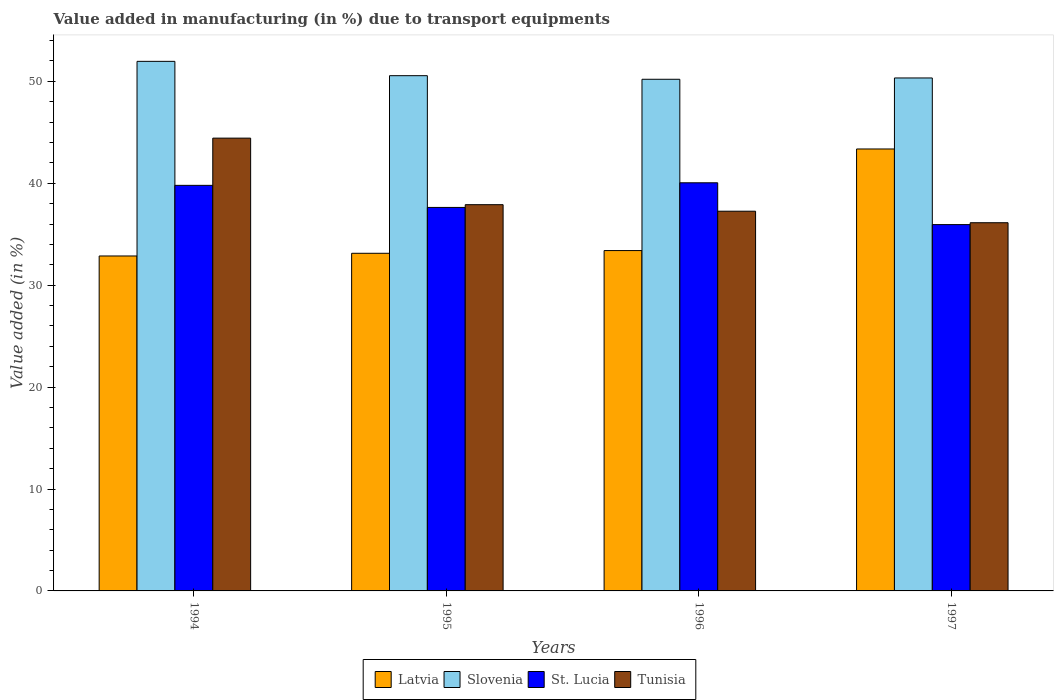How many different coloured bars are there?
Make the answer very short. 4. How many groups of bars are there?
Offer a terse response. 4. Are the number of bars on each tick of the X-axis equal?
Give a very brief answer. Yes. How many bars are there on the 1st tick from the left?
Your response must be concise. 4. How many bars are there on the 4th tick from the right?
Ensure brevity in your answer.  4. In how many cases, is the number of bars for a given year not equal to the number of legend labels?
Ensure brevity in your answer.  0. What is the percentage of value added in manufacturing due to transport equipments in Tunisia in 1994?
Offer a very short reply. 44.43. Across all years, what is the maximum percentage of value added in manufacturing due to transport equipments in Slovenia?
Give a very brief answer. 51.96. Across all years, what is the minimum percentage of value added in manufacturing due to transport equipments in Slovenia?
Make the answer very short. 50.2. In which year was the percentage of value added in manufacturing due to transport equipments in Tunisia maximum?
Provide a succinct answer. 1994. What is the total percentage of value added in manufacturing due to transport equipments in Latvia in the graph?
Ensure brevity in your answer.  142.75. What is the difference between the percentage of value added in manufacturing due to transport equipments in Slovenia in 1995 and that in 1996?
Make the answer very short. 0.35. What is the difference between the percentage of value added in manufacturing due to transport equipments in St. Lucia in 1996 and the percentage of value added in manufacturing due to transport equipments in Tunisia in 1994?
Ensure brevity in your answer.  -4.38. What is the average percentage of value added in manufacturing due to transport equipments in Slovenia per year?
Offer a very short reply. 50.76. In the year 1995, what is the difference between the percentage of value added in manufacturing due to transport equipments in Slovenia and percentage of value added in manufacturing due to transport equipments in Latvia?
Keep it short and to the point. 17.43. What is the ratio of the percentage of value added in manufacturing due to transport equipments in St. Lucia in 1996 to that in 1997?
Ensure brevity in your answer.  1.11. Is the percentage of value added in manufacturing due to transport equipments in Slovenia in 1996 less than that in 1997?
Provide a short and direct response. Yes. What is the difference between the highest and the second highest percentage of value added in manufacturing due to transport equipments in Slovenia?
Offer a terse response. 1.41. What is the difference between the highest and the lowest percentage of value added in manufacturing due to transport equipments in Latvia?
Ensure brevity in your answer.  10.5. Is the sum of the percentage of value added in manufacturing due to transport equipments in Tunisia in 1995 and 1997 greater than the maximum percentage of value added in manufacturing due to transport equipments in Latvia across all years?
Provide a short and direct response. Yes. What does the 3rd bar from the left in 1995 represents?
Your answer should be compact. St. Lucia. What does the 4th bar from the right in 1997 represents?
Keep it short and to the point. Latvia. Is it the case that in every year, the sum of the percentage of value added in manufacturing due to transport equipments in Slovenia and percentage of value added in manufacturing due to transport equipments in St. Lucia is greater than the percentage of value added in manufacturing due to transport equipments in Tunisia?
Keep it short and to the point. Yes. How many bars are there?
Provide a short and direct response. 16. Are all the bars in the graph horizontal?
Offer a very short reply. No. What is the difference between two consecutive major ticks on the Y-axis?
Ensure brevity in your answer.  10. Are the values on the major ticks of Y-axis written in scientific E-notation?
Provide a succinct answer. No. Where does the legend appear in the graph?
Provide a short and direct response. Bottom center. How are the legend labels stacked?
Your answer should be compact. Horizontal. What is the title of the graph?
Your answer should be compact. Value added in manufacturing (in %) due to transport equipments. What is the label or title of the Y-axis?
Your answer should be very brief. Value added (in %). What is the Value added (in %) in Latvia in 1994?
Your response must be concise. 32.86. What is the Value added (in %) in Slovenia in 1994?
Your response must be concise. 51.96. What is the Value added (in %) of St. Lucia in 1994?
Give a very brief answer. 39.79. What is the Value added (in %) in Tunisia in 1994?
Offer a very short reply. 44.43. What is the Value added (in %) of Latvia in 1995?
Offer a very short reply. 33.13. What is the Value added (in %) of Slovenia in 1995?
Provide a short and direct response. 50.55. What is the Value added (in %) in St. Lucia in 1995?
Provide a succinct answer. 37.63. What is the Value added (in %) in Tunisia in 1995?
Keep it short and to the point. 37.9. What is the Value added (in %) of Latvia in 1996?
Offer a terse response. 33.39. What is the Value added (in %) of Slovenia in 1996?
Offer a terse response. 50.2. What is the Value added (in %) of St. Lucia in 1996?
Offer a terse response. 40.05. What is the Value added (in %) in Tunisia in 1996?
Your answer should be very brief. 37.26. What is the Value added (in %) of Latvia in 1997?
Your answer should be compact. 43.36. What is the Value added (in %) of Slovenia in 1997?
Keep it short and to the point. 50.33. What is the Value added (in %) in St. Lucia in 1997?
Give a very brief answer. 35.94. What is the Value added (in %) in Tunisia in 1997?
Give a very brief answer. 36.13. Across all years, what is the maximum Value added (in %) of Latvia?
Ensure brevity in your answer.  43.36. Across all years, what is the maximum Value added (in %) of Slovenia?
Provide a succinct answer. 51.96. Across all years, what is the maximum Value added (in %) of St. Lucia?
Your response must be concise. 40.05. Across all years, what is the maximum Value added (in %) in Tunisia?
Provide a succinct answer. 44.43. Across all years, what is the minimum Value added (in %) of Latvia?
Provide a succinct answer. 32.86. Across all years, what is the minimum Value added (in %) in Slovenia?
Provide a short and direct response. 50.2. Across all years, what is the minimum Value added (in %) in St. Lucia?
Ensure brevity in your answer.  35.94. Across all years, what is the minimum Value added (in %) in Tunisia?
Your answer should be compact. 36.13. What is the total Value added (in %) in Latvia in the graph?
Ensure brevity in your answer.  142.75. What is the total Value added (in %) of Slovenia in the graph?
Your response must be concise. 203.05. What is the total Value added (in %) of St. Lucia in the graph?
Give a very brief answer. 153.41. What is the total Value added (in %) of Tunisia in the graph?
Your answer should be very brief. 155.71. What is the difference between the Value added (in %) in Latvia in 1994 and that in 1995?
Offer a terse response. -0.26. What is the difference between the Value added (in %) in Slovenia in 1994 and that in 1995?
Make the answer very short. 1.41. What is the difference between the Value added (in %) in St. Lucia in 1994 and that in 1995?
Offer a terse response. 2.17. What is the difference between the Value added (in %) in Tunisia in 1994 and that in 1995?
Offer a very short reply. 6.53. What is the difference between the Value added (in %) in Latvia in 1994 and that in 1996?
Offer a terse response. -0.53. What is the difference between the Value added (in %) in Slovenia in 1994 and that in 1996?
Provide a succinct answer. 1.76. What is the difference between the Value added (in %) in St. Lucia in 1994 and that in 1996?
Offer a terse response. -0.25. What is the difference between the Value added (in %) of Tunisia in 1994 and that in 1996?
Keep it short and to the point. 7.17. What is the difference between the Value added (in %) of Latvia in 1994 and that in 1997?
Provide a succinct answer. -10.5. What is the difference between the Value added (in %) in Slovenia in 1994 and that in 1997?
Ensure brevity in your answer.  1.63. What is the difference between the Value added (in %) in St. Lucia in 1994 and that in 1997?
Make the answer very short. 3.85. What is the difference between the Value added (in %) in Tunisia in 1994 and that in 1997?
Your response must be concise. 8.3. What is the difference between the Value added (in %) in Latvia in 1995 and that in 1996?
Provide a short and direct response. -0.27. What is the difference between the Value added (in %) of Slovenia in 1995 and that in 1996?
Your answer should be very brief. 0.35. What is the difference between the Value added (in %) in St. Lucia in 1995 and that in 1996?
Ensure brevity in your answer.  -2.42. What is the difference between the Value added (in %) in Tunisia in 1995 and that in 1996?
Offer a terse response. 0.64. What is the difference between the Value added (in %) of Latvia in 1995 and that in 1997?
Give a very brief answer. -10.23. What is the difference between the Value added (in %) in Slovenia in 1995 and that in 1997?
Provide a short and direct response. 0.22. What is the difference between the Value added (in %) in St. Lucia in 1995 and that in 1997?
Your response must be concise. 1.68. What is the difference between the Value added (in %) in Tunisia in 1995 and that in 1997?
Your response must be concise. 1.77. What is the difference between the Value added (in %) of Latvia in 1996 and that in 1997?
Offer a terse response. -9.97. What is the difference between the Value added (in %) in Slovenia in 1996 and that in 1997?
Your answer should be compact. -0.13. What is the difference between the Value added (in %) of St. Lucia in 1996 and that in 1997?
Provide a short and direct response. 4.1. What is the difference between the Value added (in %) of Tunisia in 1996 and that in 1997?
Offer a very short reply. 1.13. What is the difference between the Value added (in %) in Latvia in 1994 and the Value added (in %) in Slovenia in 1995?
Provide a short and direct response. -17.69. What is the difference between the Value added (in %) in Latvia in 1994 and the Value added (in %) in St. Lucia in 1995?
Offer a very short reply. -4.76. What is the difference between the Value added (in %) in Latvia in 1994 and the Value added (in %) in Tunisia in 1995?
Give a very brief answer. -5.03. What is the difference between the Value added (in %) of Slovenia in 1994 and the Value added (in %) of St. Lucia in 1995?
Give a very brief answer. 14.33. What is the difference between the Value added (in %) of Slovenia in 1994 and the Value added (in %) of Tunisia in 1995?
Keep it short and to the point. 14.06. What is the difference between the Value added (in %) of St. Lucia in 1994 and the Value added (in %) of Tunisia in 1995?
Your response must be concise. 1.9. What is the difference between the Value added (in %) of Latvia in 1994 and the Value added (in %) of Slovenia in 1996?
Make the answer very short. -17.34. What is the difference between the Value added (in %) in Latvia in 1994 and the Value added (in %) in St. Lucia in 1996?
Make the answer very short. -7.18. What is the difference between the Value added (in %) of Latvia in 1994 and the Value added (in %) of Tunisia in 1996?
Your response must be concise. -4.39. What is the difference between the Value added (in %) of Slovenia in 1994 and the Value added (in %) of St. Lucia in 1996?
Your response must be concise. 11.92. What is the difference between the Value added (in %) of Slovenia in 1994 and the Value added (in %) of Tunisia in 1996?
Make the answer very short. 14.7. What is the difference between the Value added (in %) in St. Lucia in 1994 and the Value added (in %) in Tunisia in 1996?
Provide a succinct answer. 2.54. What is the difference between the Value added (in %) of Latvia in 1994 and the Value added (in %) of Slovenia in 1997?
Give a very brief answer. -17.47. What is the difference between the Value added (in %) in Latvia in 1994 and the Value added (in %) in St. Lucia in 1997?
Your answer should be compact. -3.08. What is the difference between the Value added (in %) of Latvia in 1994 and the Value added (in %) of Tunisia in 1997?
Make the answer very short. -3.26. What is the difference between the Value added (in %) of Slovenia in 1994 and the Value added (in %) of St. Lucia in 1997?
Make the answer very short. 16.02. What is the difference between the Value added (in %) of Slovenia in 1994 and the Value added (in %) of Tunisia in 1997?
Give a very brief answer. 15.83. What is the difference between the Value added (in %) of St. Lucia in 1994 and the Value added (in %) of Tunisia in 1997?
Offer a very short reply. 3.67. What is the difference between the Value added (in %) of Latvia in 1995 and the Value added (in %) of Slovenia in 1996?
Your response must be concise. -17.07. What is the difference between the Value added (in %) of Latvia in 1995 and the Value added (in %) of St. Lucia in 1996?
Your answer should be very brief. -6.92. What is the difference between the Value added (in %) in Latvia in 1995 and the Value added (in %) in Tunisia in 1996?
Offer a terse response. -4.13. What is the difference between the Value added (in %) in Slovenia in 1995 and the Value added (in %) in St. Lucia in 1996?
Your answer should be very brief. 10.51. What is the difference between the Value added (in %) of Slovenia in 1995 and the Value added (in %) of Tunisia in 1996?
Keep it short and to the point. 13.3. What is the difference between the Value added (in %) of St. Lucia in 1995 and the Value added (in %) of Tunisia in 1996?
Your answer should be compact. 0.37. What is the difference between the Value added (in %) in Latvia in 1995 and the Value added (in %) in Slovenia in 1997?
Provide a short and direct response. -17.2. What is the difference between the Value added (in %) of Latvia in 1995 and the Value added (in %) of St. Lucia in 1997?
Give a very brief answer. -2.82. What is the difference between the Value added (in %) in Latvia in 1995 and the Value added (in %) in Tunisia in 1997?
Offer a terse response. -3. What is the difference between the Value added (in %) in Slovenia in 1995 and the Value added (in %) in St. Lucia in 1997?
Your response must be concise. 14.61. What is the difference between the Value added (in %) in Slovenia in 1995 and the Value added (in %) in Tunisia in 1997?
Your answer should be compact. 14.43. What is the difference between the Value added (in %) in St. Lucia in 1995 and the Value added (in %) in Tunisia in 1997?
Offer a very short reply. 1.5. What is the difference between the Value added (in %) of Latvia in 1996 and the Value added (in %) of Slovenia in 1997?
Make the answer very short. -16.94. What is the difference between the Value added (in %) of Latvia in 1996 and the Value added (in %) of St. Lucia in 1997?
Give a very brief answer. -2.55. What is the difference between the Value added (in %) in Latvia in 1996 and the Value added (in %) in Tunisia in 1997?
Provide a short and direct response. -2.73. What is the difference between the Value added (in %) in Slovenia in 1996 and the Value added (in %) in St. Lucia in 1997?
Ensure brevity in your answer.  14.26. What is the difference between the Value added (in %) of Slovenia in 1996 and the Value added (in %) of Tunisia in 1997?
Provide a short and direct response. 14.08. What is the difference between the Value added (in %) in St. Lucia in 1996 and the Value added (in %) in Tunisia in 1997?
Make the answer very short. 3.92. What is the average Value added (in %) of Latvia per year?
Give a very brief answer. 35.69. What is the average Value added (in %) in Slovenia per year?
Your answer should be compact. 50.76. What is the average Value added (in %) of St. Lucia per year?
Offer a very short reply. 38.35. What is the average Value added (in %) in Tunisia per year?
Keep it short and to the point. 38.93. In the year 1994, what is the difference between the Value added (in %) in Latvia and Value added (in %) in Slovenia?
Your response must be concise. -19.1. In the year 1994, what is the difference between the Value added (in %) of Latvia and Value added (in %) of St. Lucia?
Provide a short and direct response. -6.93. In the year 1994, what is the difference between the Value added (in %) of Latvia and Value added (in %) of Tunisia?
Keep it short and to the point. -11.56. In the year 1994, what is the difference between the Value added (in %) of Slovenia and Value added (in %) of St. Lucia?
Give a very brief answer. 12.17. In the year 1994, what is the difference between the Value added (in %) in Slovenia and Value added (in %) in Tunisia?
Your response must be concise. 7.53. In the year 1994, what is the difference between the Value added (in %) in St. Lucia and Value added (in %) in Tunisia?
Offer a very short reply. -4.63. In the year 1995, what is the difference between the Value added (in %) in Latvia and Value added (in %) in Slovenia?
Your answer should be very brief. -17.43. In the year 1995, what is the difference between the Value added (in %) of Latvia and Value added (in %) of St. Lucia?
Ensure brevity in your answer.  -4.5. In the year 1995, what is the difference between the Value added (in %) in Latvia and Value added (in %) in Tunisia?
Ensure brevity in your answer.  -4.77. In the year 1995, what is the difference between the Value added (in %) of Slovenia and Value added (in %) of St. Lucia?
Make the answer very short. 12.93. In the year 1995, what is the difference between the Value added (in %) of Slovenia and Value added (in %) of Tunisia?
Offer a very short reply. 12.66. In the year 1995, what is the difference between the Value added (in %) of St. Lucia and Value added (in %) of Tunisia?
Offer a very short reply. -0.27. In the year 1996, what is the difference between the Value added (in %) of Latvia and Value added (in %) of Slovenia?
Your response must be concise. -16.81. In the year 1996, what is the difference between the Value added (in %) of Latvia and Value added (in %) of St. Lucia?
Provide a short and direct response. -6.65. In the year 1996, what is the difference between the Value added (in %) of Latvia and Value added (in %) of Tunisia?
Your answer should be very brief. -3.86. In the year 1996, what is the difference between the Value added (in %) in Slovenia and Value added (in %) in St. Lucia?
Ensure brevity in your answer.  10.16. In the year 1996, what is the difference between the Value added (in %) of Slovenia and Value added (in %) of Tunisia?
Keep it short and to the point. 12.95. In the year 1996, what is the difference between the Value added (in %) in St. Lucia and Value added (in %) in Tunisia?
Your answer should be very brief. 2.79. In the year 1997, what is the difference between the Value added (in %) of Latvia and Value added (in %) of Slovenia?
Your answer should be very brief. -6.97. In the year 1997, what is the difference between the Value added (in %) in Latvia and Value added (in %) in St. Lucia?
Offer a very short reply. 7.42. In the year 1997, what is the difference between the Value added (in %) in Latvia and Value added (in %) in Tunisia?
Your answer should be compact. 7.24. In the year 1997, what is the difference between the Value added (in %) of Slovenia and Value added (in %) of St. Lucia?
Make the answer very short. 14.39. In the year 1997, what is the difference between the Value added (in %) in Slovenia and Value added (in %) in Tunisia?
Your response must be concise. 14.21. In the year 1997, what is the difference between the Value added (in %) in St. Lucia and Value added (in %) in Tunisia?
Your answer should be compact. -0.18. What is the ratio of the Value added (in %) of Slovenia in 1994 to that in 1995?
Ensure brevity in your answer.  1.03. What is the ratio of the Value added (in %) in St. Lucia in 1994 to that in 1995?
Your response must be concise. 1.06. What is the ratio of the Value added (in %) of Tunisia in 1994 to that in 1995?
Give a very brief answer. 1.17. What is the ratio of the Value added (in %) in Latvia in 1994 to that in 1996?
Your response must be concise. 0.98. What is the ratio of the Value added (in %) of Slovenia in 1994 to that in 1996?
Provide a short and direct response. 1.03. What is the ratio of the Value added (in %) in Tunisia in 1994 to that in 1996?
Offer a very short reply. 1.19. What is the ratio of the Value added (in %) in Latvia in 1994 to that in 1997?
Make the answer very short. 0.76. What is the ratio of the Value added (in %) of Slovenia in 1994 to that in 1997?
Offer a terse response. 1.03. What is the ratio of the Value added (in %) of St. Lucia in 1994 to that in 1997?
Make the answer very short. 1.11. What is the ratio of the Value added (in %) of Tunisia in 1994 to that in 1997?
Provide a short and direct response. 1.23. What is the ratio of the Value added (in %) of St. Lucia in 1995 to that in 1996?
Your answer should be very brief. 0.94. What is the ratio of the Value added (in %) of Tunisia in 1995 to that in 1996?
Ensure brevity in your answer.  1.02. What is the ratio of the Value added (in %) in Latvia in 1995 to that in 1997?
Ensure brevity in your answer.  0.76. What is the ratio of the Value added (in %) of St. Lucia in 1995 to that in 1997?
Make the answer very short. 1.05. What is the ratio of the Value added (in %) of Tunisia in 1995 to that in 1997?
Your answer should be very brief. 1.05. What is the ratio of the Value added (in %) of Latvia in 1996 to that in 1997?
Offer a very short reply. 0.77. What is the ratio of the Value added (in %) of St. Lucia in 1996 to that in 1997?
Ensure brevity in your answer.  1.11. What is the ratio of the Value added (in %) of Tunisia in 1996 to that in 1997?
Provide a short and direct response. 1.03. What is the difference between the highest and the second highest Value added (in %) of Latvia?
Provide a short and direct response. 9.97. What is the difference between the highest and the second highest Value added (in %) in Slovenia?
Provide a short and direct response. 1.41. What is the difference between the highest and the second highest Value added (in %) of St. Lucia?
Your answer should be very brief. 0.25. What is the difference between the highest and the second highest Value added (in %) of Tunisia?
Make the answer very short. 6.53. What is the difference between the highest and the lowest Value added (in %) in Latvia?
Your answer should be compact. 10.5. What is the difference between the highest and the lowest Value added (in %) of Slovenia?
Your answer should be compact. 1.76. What is the difference between the highest and the lowest Value added (in %) of St. Lucia?
Offer a terse response. 4.1. What is the difference between the highest and the lowest Value added (in %) of Tunisia?
Ensure brevity in your answer.  8.3. 